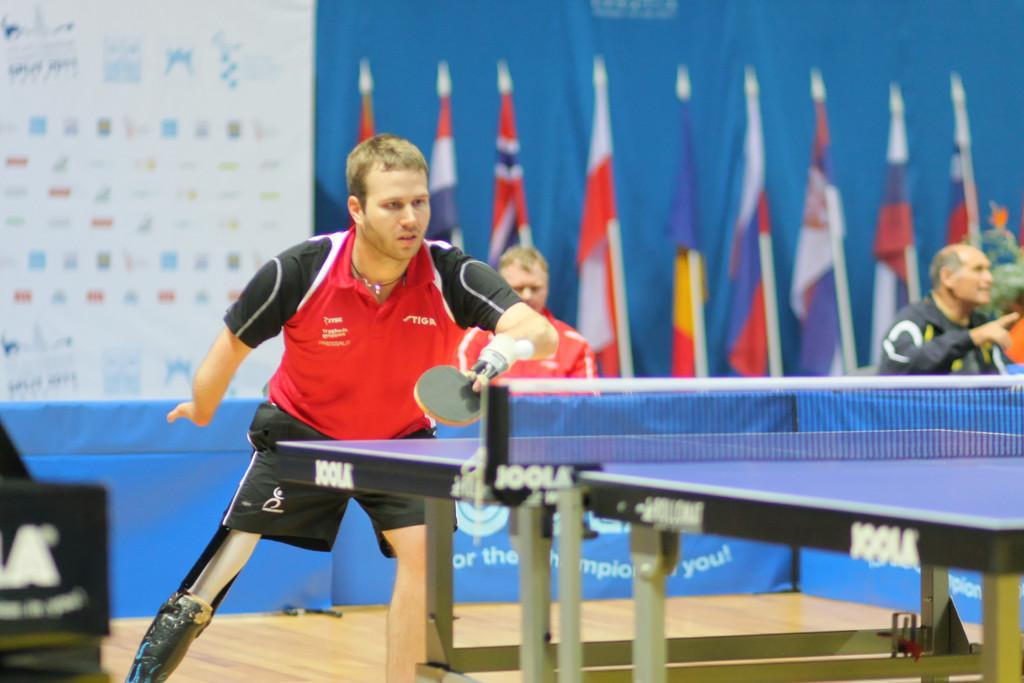<image>
Give a short and clear explanation of the subsequent image. Man playing ping pong wearing a shirt that says "STIGA". 